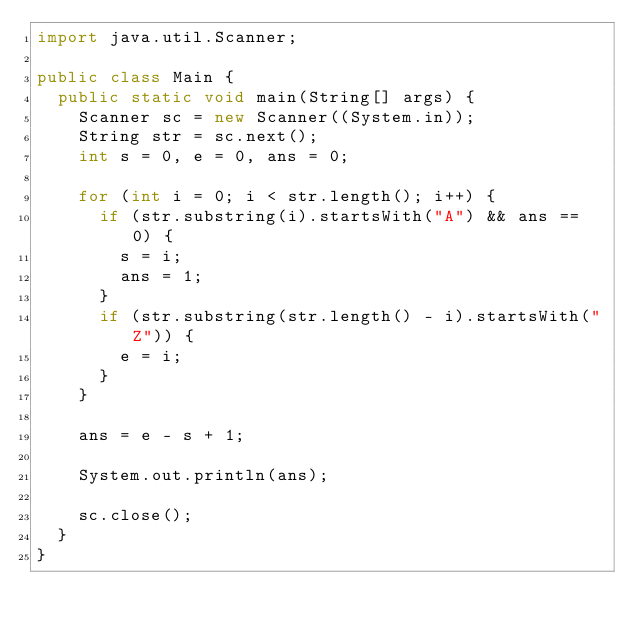<code> <loc_0><loc_0><loc_500><loc_500><_Java_>import java.util.Scanner;

public class Main {
	public static void main(String[] args) {
		Scanner sc = new Scanner((System.in));
		String str = sc.next();
		int s = 0, e = 0, ans = 0;
		
		for (int i = 0; i < str.length(); i++) {
			if (str.substring(i).startsWith("A") && ans == 0) {
				s = i;
				ans = 1;
			}
			if (str.substring(str.length() - i).startsWith("Z")) {
				e = i;
			}
		}
		
		ans = e - s + 1;
		
		System.out.println(ans);

		sc.close();
	}
}
</code> 